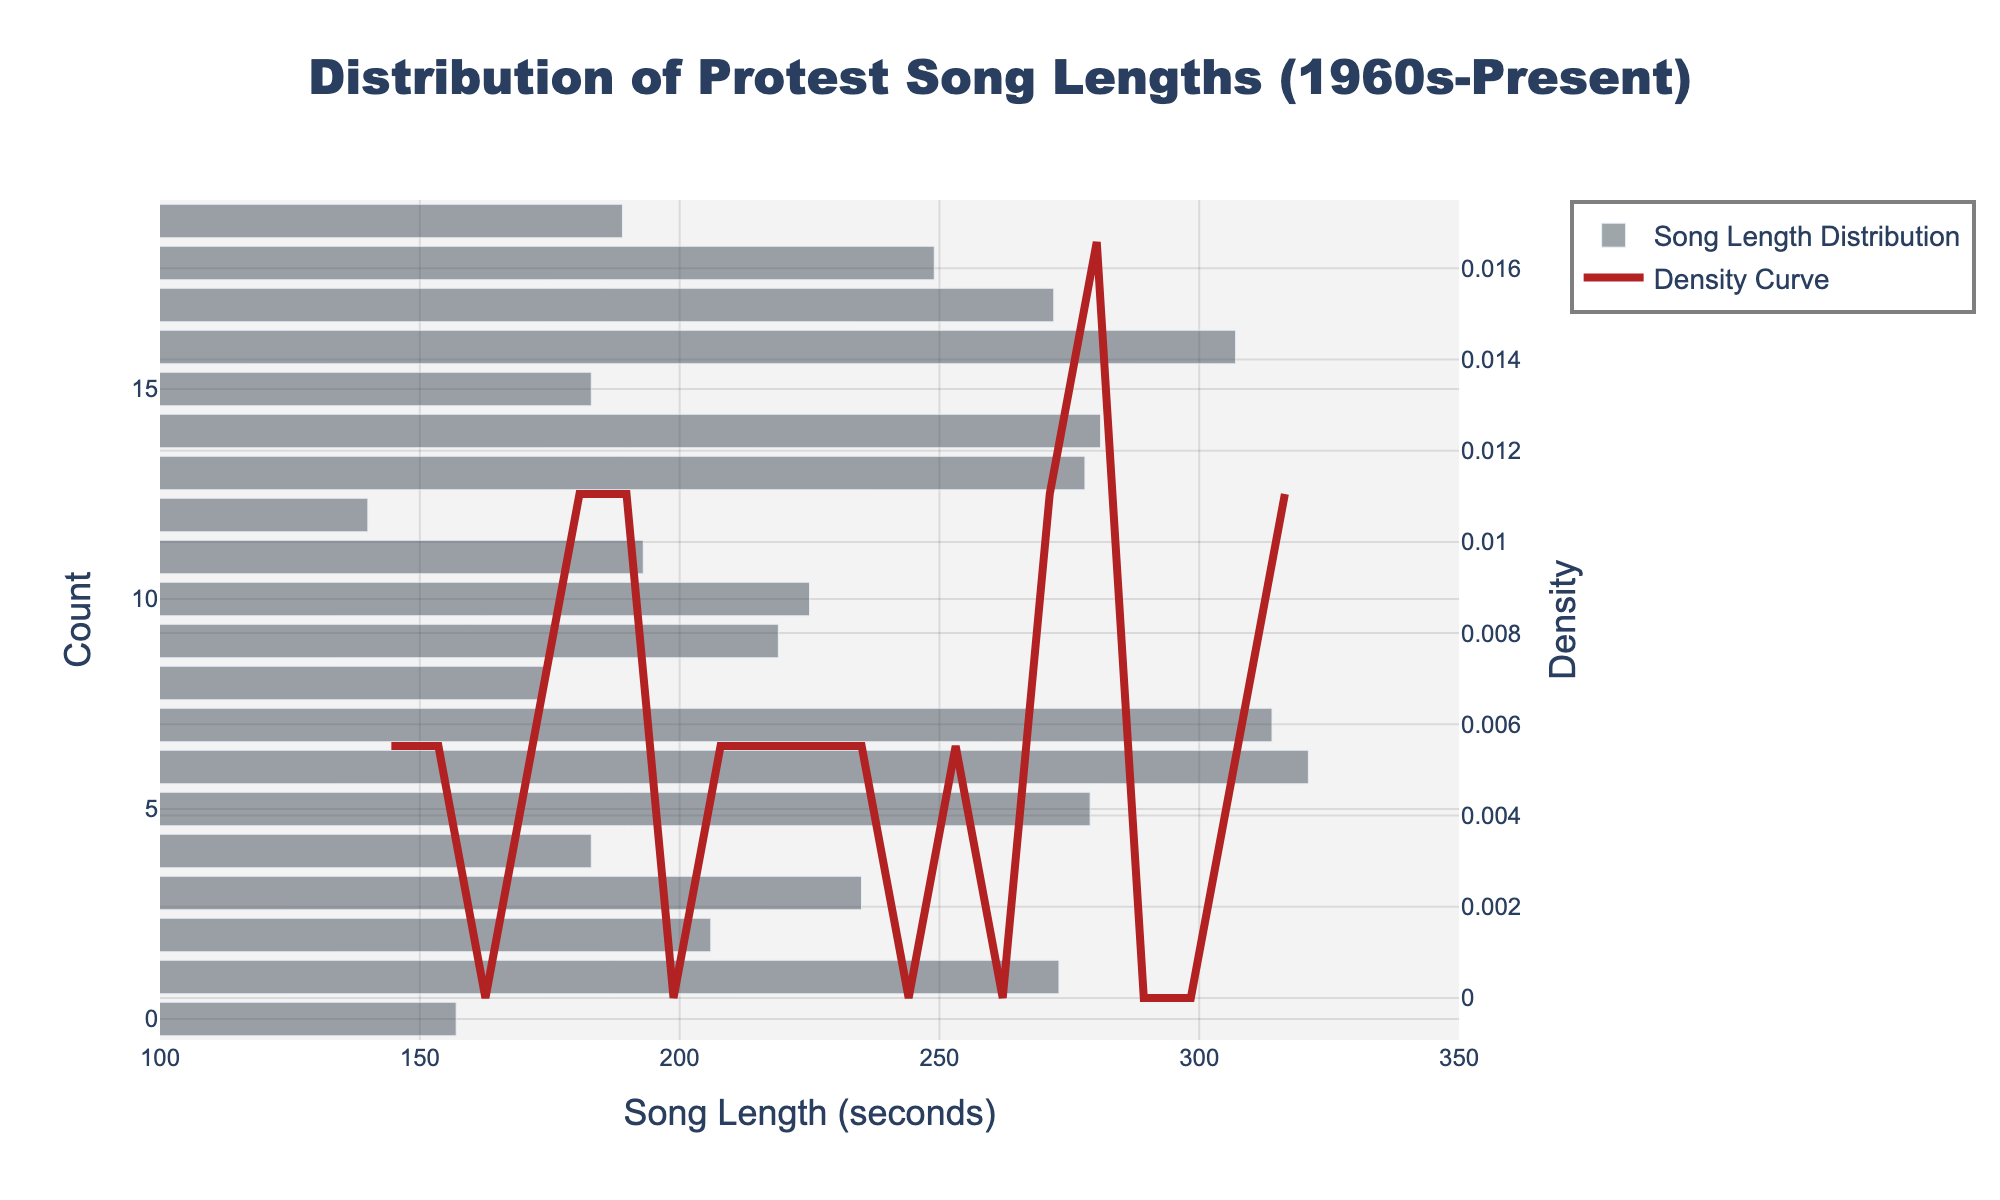What is the title of the histogram? The title is usually displayed prominently at the top of the chart. In this case, it reads 'Distribution of Protest Song Lengths (1960s-Present)'.
Answer: Distribution of Protest Song Lengths (1960s-Present) What does the x-axis represent? The x-axis typically represents the variable being measured. Here, it is labeled as 'Song Length (seconds)', indicating song durations on the x-axis.
Answer: Song Length (seconds) What does the primary y-axis represent? The primary y-axis in this histogram is labeled 'Count', meaning it represents the number of songs within each bin (range) of lengths.
Answer: Count What does the secondary y-axis represent? The secondary y-axis, which is used for the KDE curve, is labeled 'Density'. This shows the estimated probability density of the song lengths.
Answer: Density What is the range of song lengths displayed in the histogram? By observing where the bars start and end on the x-axis, the song lengths range approximately from 100 seconds to 350 seconds.
Answer: 100 to 350 seconds Which song length appears to be the most frequent (mode) based on the histogram? By looking at the height of the bars, the tallest bar indicates the mode. Here, it seems to be around 180 seconds.
Answer: Around 180 seconds How does the density curve help in understanding the distribution of song lengths? The density curve (KDE) smooths out the frequency data to give an estimate of the probability density function. It shows the overall shape and trends of the distribution, highlighting peaks and valleys, which may not be as evident in the histogram alone.
Answer: It shows overall trends and distribution shape Are there any visible peaks in the density curve? Where are they located? Peaks in the density curve represent where song lengths are most densely distributed. There's a peak around 180 seconds and another smaller one around 270 seconds.
Answer: Around 180 seconds and 270 seconds Which has more songs: those with lengths around 150 seconds or those with lengths around 300 seconds? By comparing the heights of the bars near these values, songs around 150 seconds have a higher count than those around 300 seconds.
Answer: 150 seconds Is the song length distribution skewed? If so, how? The density curve can show skewness in the distribution. If the curve's peak is off-center or there's a longer tail on one side, it indicates skewness. Here, the distribution seems slightly right-skewed with a longer tail towards longer songs.
Answer: Slightly right-skewed 